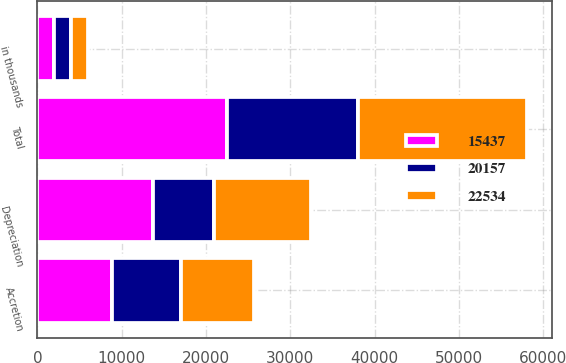Convert chart. <chart><loc_0><loc_0><loc_500><loc_500><stacked_bar_chart><ecel><fcel>in thousands<fcel>Accretion<fcel>Depreciation<fcel>Total<nl><fcel>20157<fcel>2011<fcel>8195<fcel>7242<fcel>15437<nl><fcel>22534<fcel>2010<fcel>8641<fcel>11516<fcel>20157<nl><fcel>15437<fcel>2009<fcel>8802<fcel>13732<fcel>22534<nl></chart> 